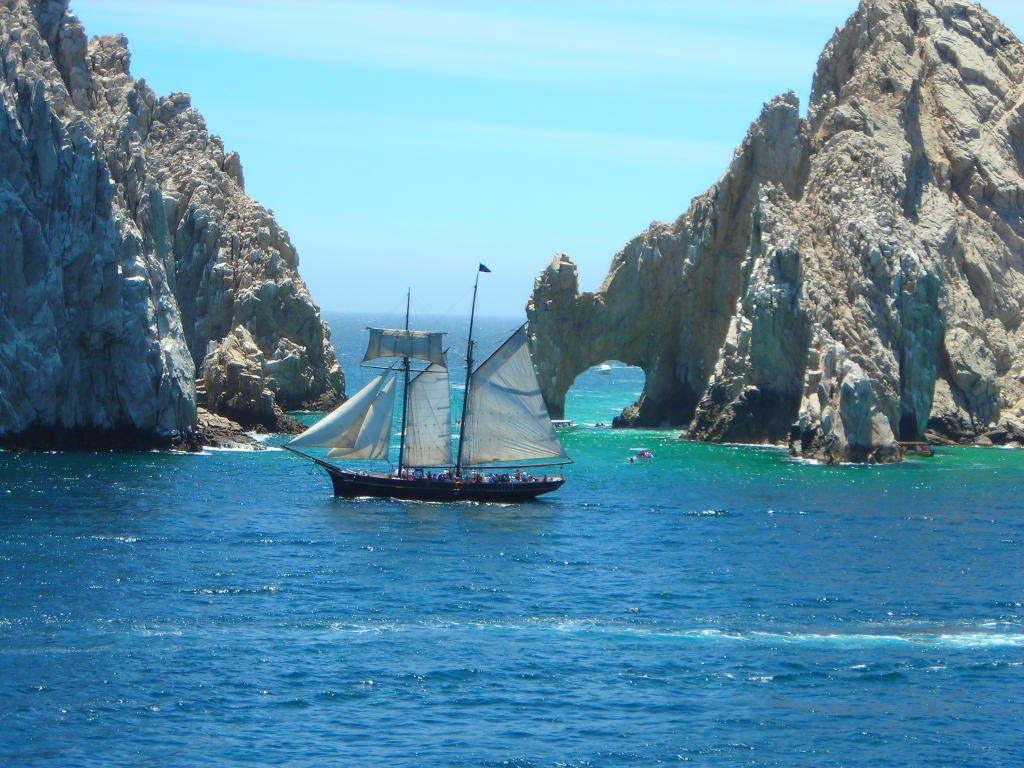Can you describe this image briefly? In this image, I can see a boat moving on the water. On the left and right side of the image, these look like the hills. At the top of the image, I can see the sky. 